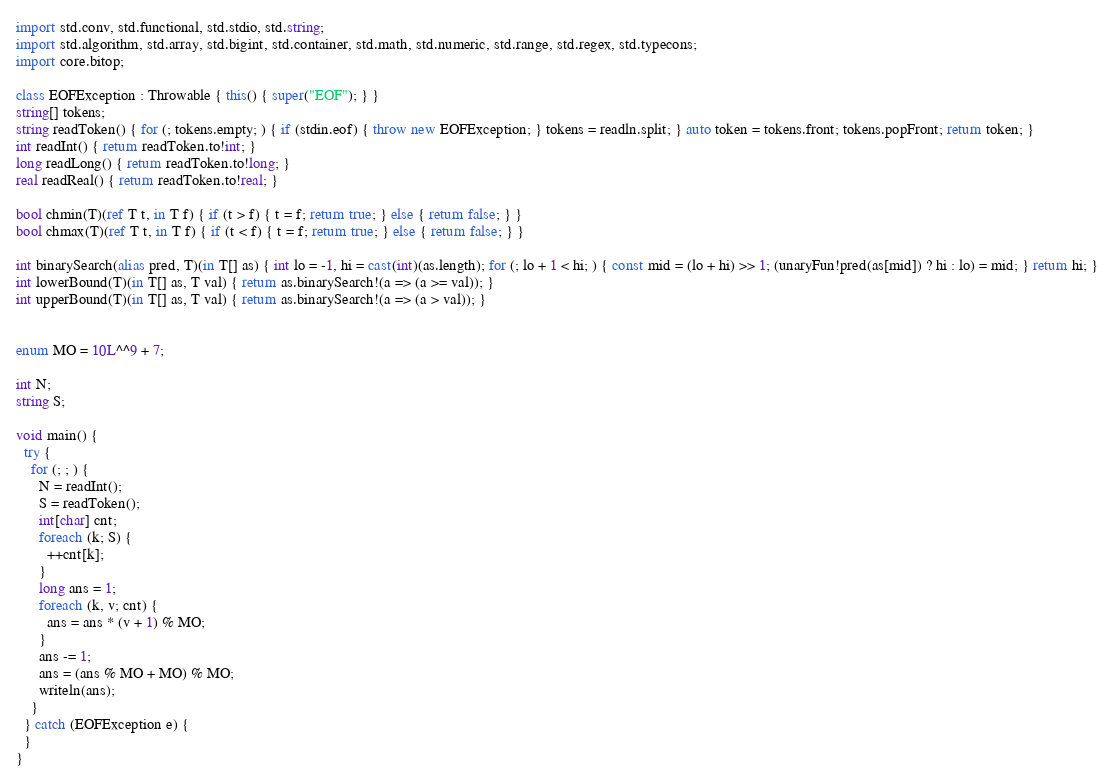Convert code to text. <code><loc_0><loc_0><loc_500><loc_500><_D_>import std.conv, std.functional, std.stdio, std.string;
import std.algorithm, std.array, std.bigint, std.container, std.math, std.numeric, std.range, std.regex, std.typecons;
import core.bitop;

class EOFException : Throwable { this() { super("EOF"); } }
string[] tokens;
string readToken() { for (; tokens.empty; ) { if (stdin.eof) { throw new EOFException; } tokens = readln.split; } auto token = tokens.front; tokens.popFront; return token; }
int readInt() { return readToken.to!int; }
long readLong() { return readToken.to!long; }
real readReal() { return readToken.to!real; }

bool chmin(T)(ref T t, in T f) { if (t > f) { t = f; return true; } else { return false; } }
bool chmax(T)(ref T t, in T f) { if (t < f) { t = f; return true; } else { return false; } }

int binarySearch(alias pred, T)(in T[] as) { int lo = -1, hi = cast(int)(as.length); for (; lo + 1 < hi; ) { const mid = (lo + hi) >> 1; (unaryFun!pred(as[mid]) ? hi : lo) = mid; } return hi; }
int lowerBound(T)(in T[] as, T val) { return as.binarySearch!(a => (a >= val)); }
int upperBound(T)(in T[] as, T val) { return as.binarySearch!(a => (a > val)); }


enum MO = 10L^^9 + 7;

int N;
string S;

void main() {
  try {
    for (; ; ) {
      N = readInt();
      S = readToken();
      int[char] cnt;
      foreach (k; S) {
        ++cnt[k];
      }
      long ans = 1;
      foreach (k, v; cnt) {
        ans = ans * (v + 1) % MO;
      }
      ans -= 1;
      ans = (ans % MO + MO) % MO;
      writeln(ans);
    }
  } catch (EOFException e) {
  }
}
</code> 